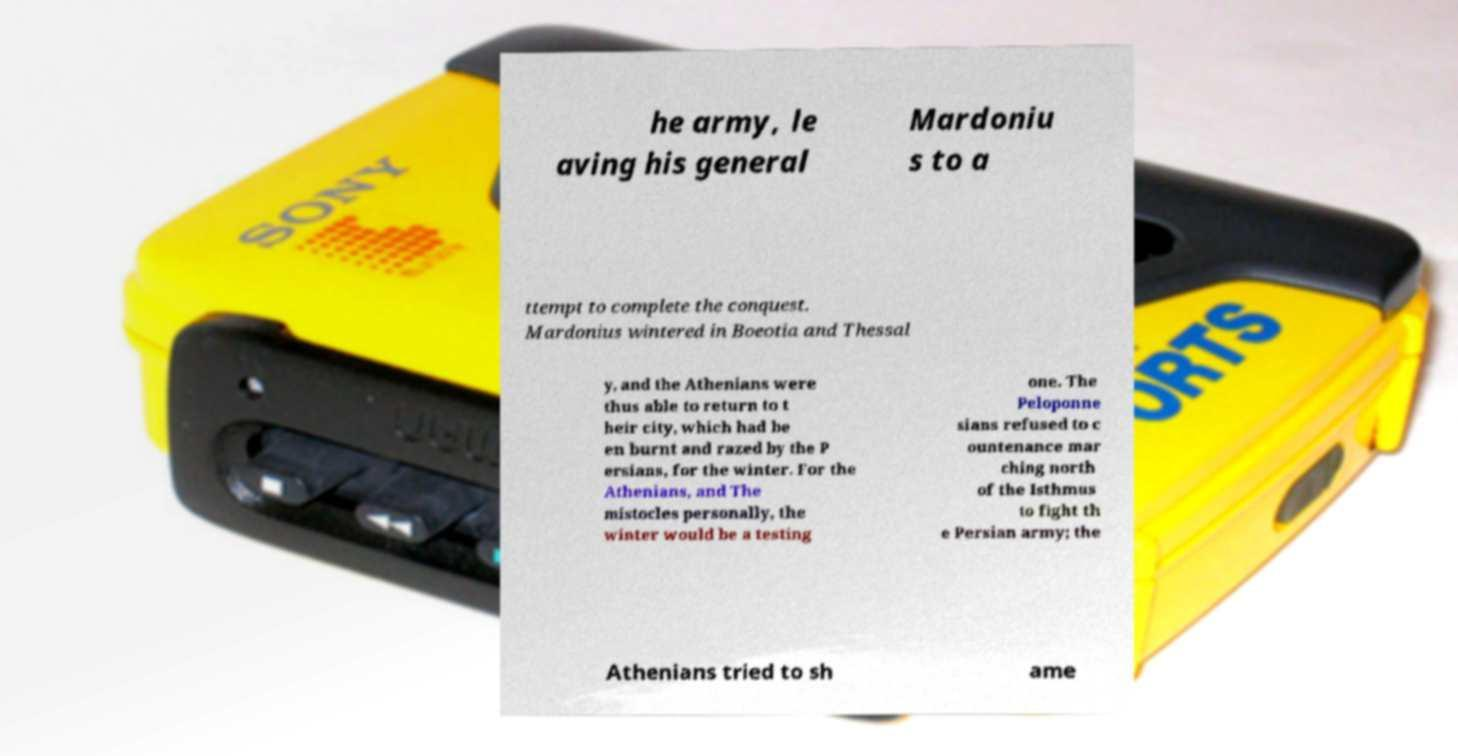There's text embedded in this image that I need extracted. Can you transcribe it verbatim? he army, le aving his general Mardoniu s to a ttempt to complete the conquest. Mardonius wintered in Boeotia and Thessal y, and the Athenians were thus able to return to t heir city, which had be en burnt and razed by the P ersians, for the winter. For the Athenians, and The mistocles personally, the winter would be a testing one. The Peloponne sians refused to c ountenance mar ching north of the Isthmus to fight th e Persian army; the Athenians tried to sh ame 